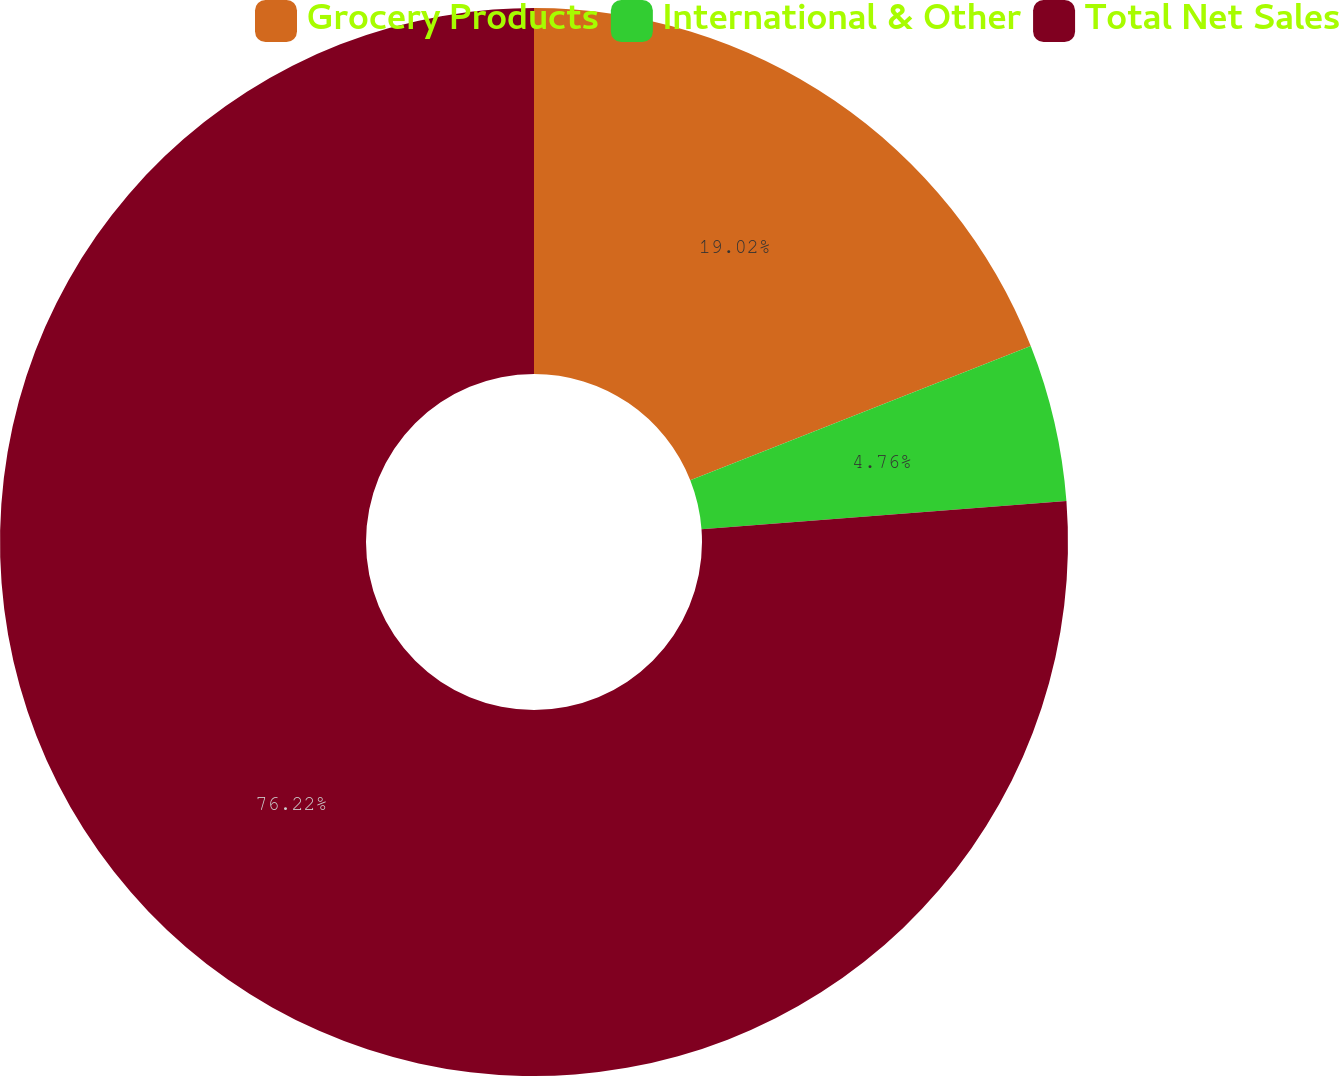Convert chart. <chart><loc_0><loc_0><loc_500><loc_500><pie_chart><fcel>Grocery Products<fcel>International & Other<fcel>Total Net Sales<nl><fcel>19.02%<fcel>4.76%<fcel>76.22%<nl></chart> 